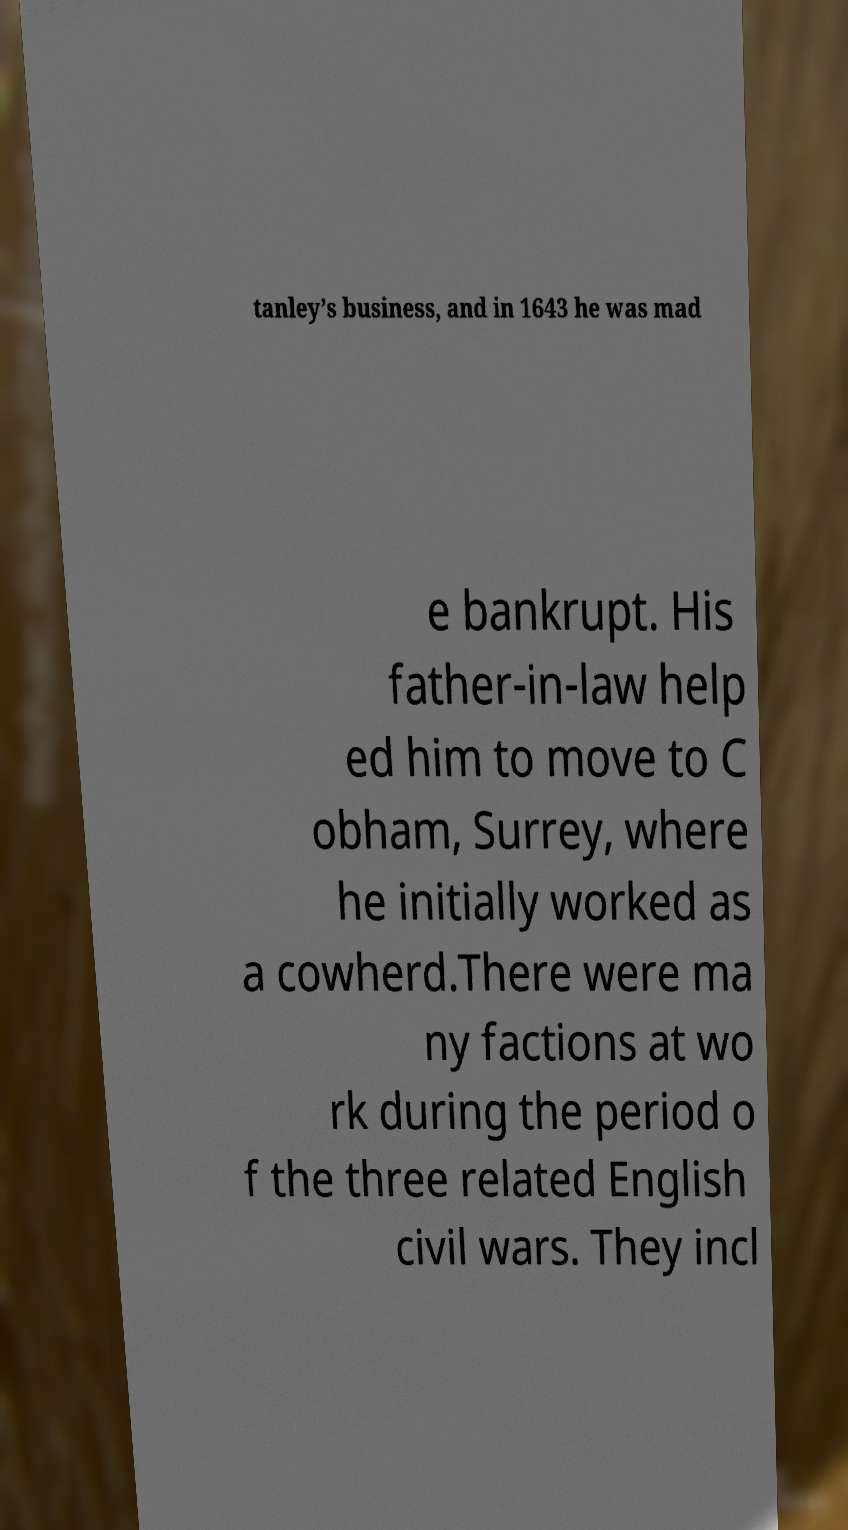What messages or text are displayed in this image? I need them in a readable, typed format. tanley’s business, and in 1643 he was mad e bankrupt. His father-in-law help ed him to move to C obham, Surrey, where he initially worked as a cowherd.There were ma ny factions at wo rk during the period o f the three related English civil wars. They incl 